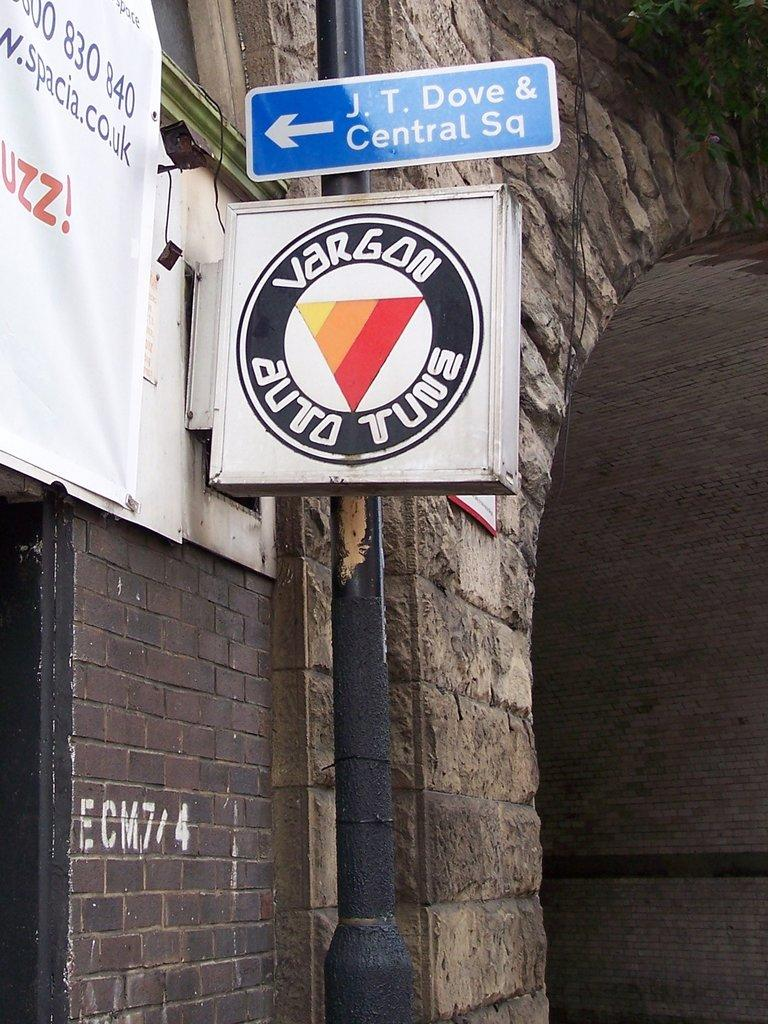Provide a one-sentence caption for the provided image. An outdoor sign for Vargon Auto is displayed. 